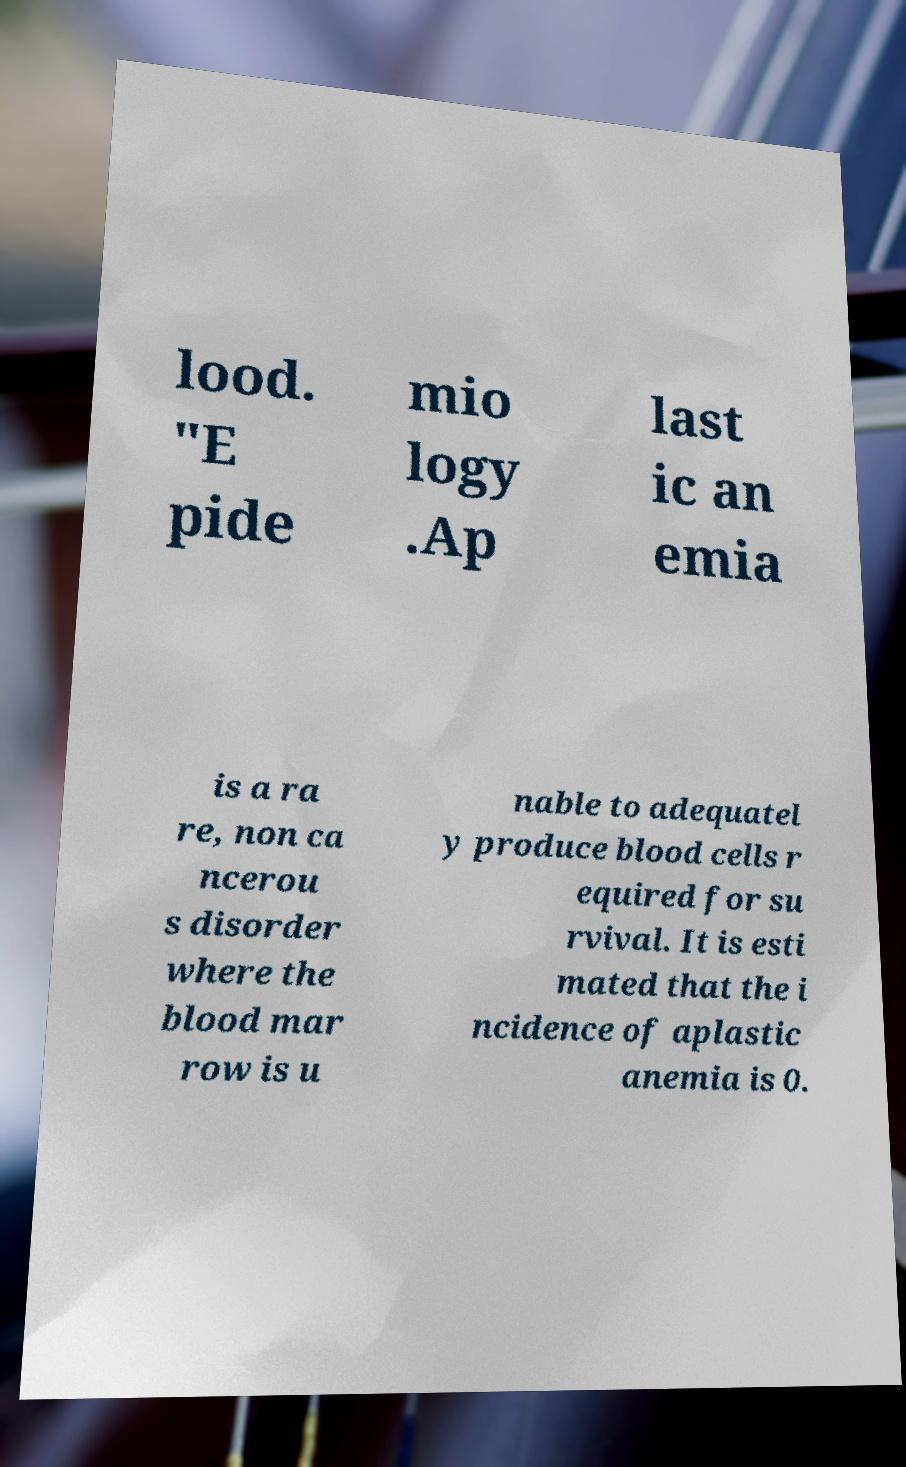What messages or text are displayed in this image? I need them in a readable, typed format. lood. "E pide mio logy .Ap last ic an emia is a ra re, non ca ncerou s disorder where the blood mar row is u nable to adequatel y produce blood cells r equired for su rvival. It is esti mated that the i ncidence of aplastic anemia is 0. 